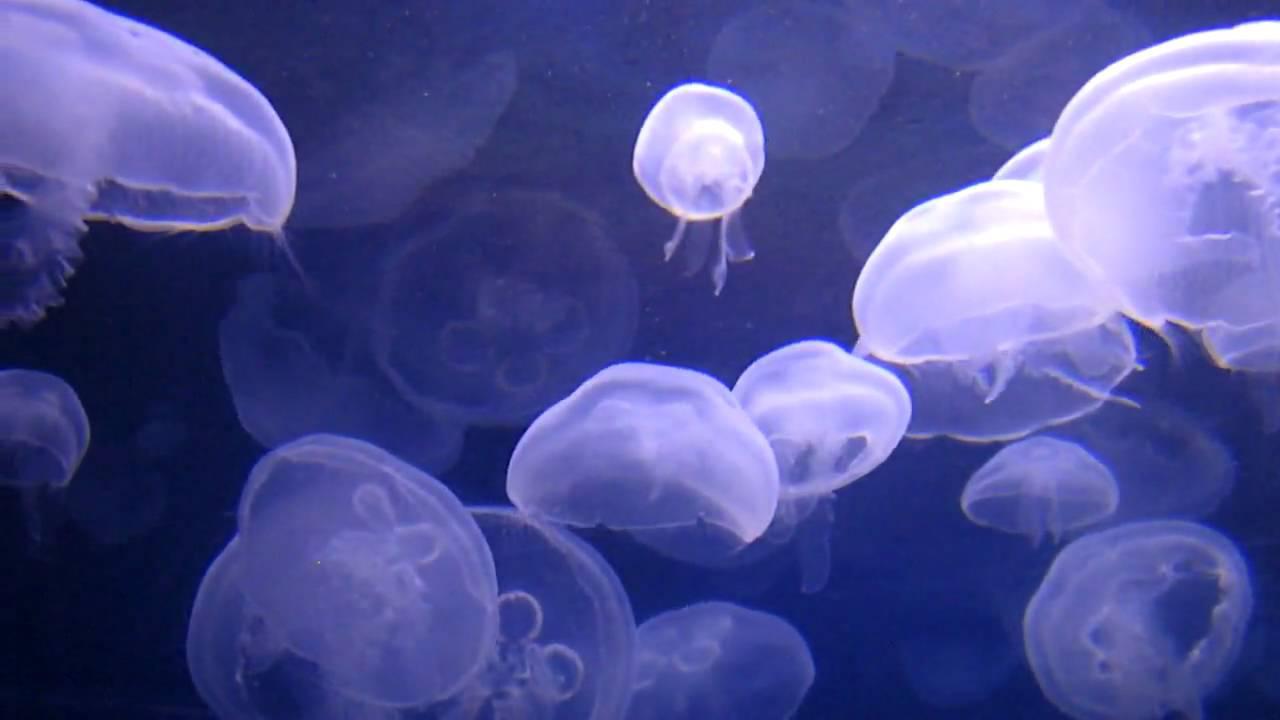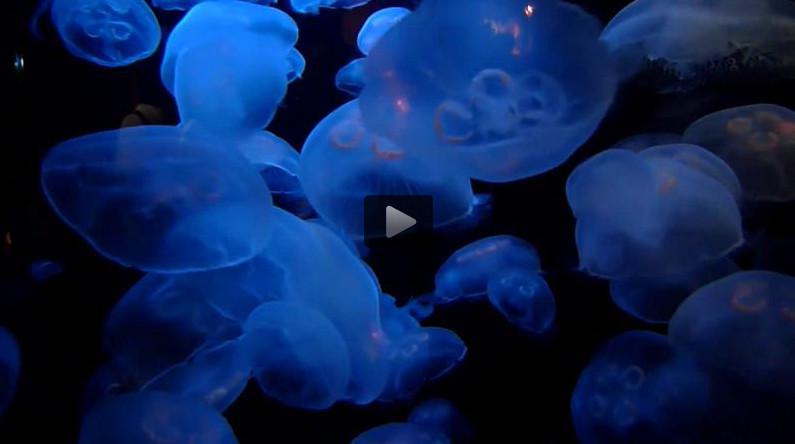The first image is the image on the left, the second image is the image on the right. Considering the images on both sides, is "There are more than twenty jellyfish." valid? Answer yes or no. Yes. The first image is the image on the left, the second image is the image on the right. Given the left and right images, does the statement "Each image contains at least ten jellyfish, and no jellyfish have thread-like tentacles." hold true? Answer yes or no. Yes. 